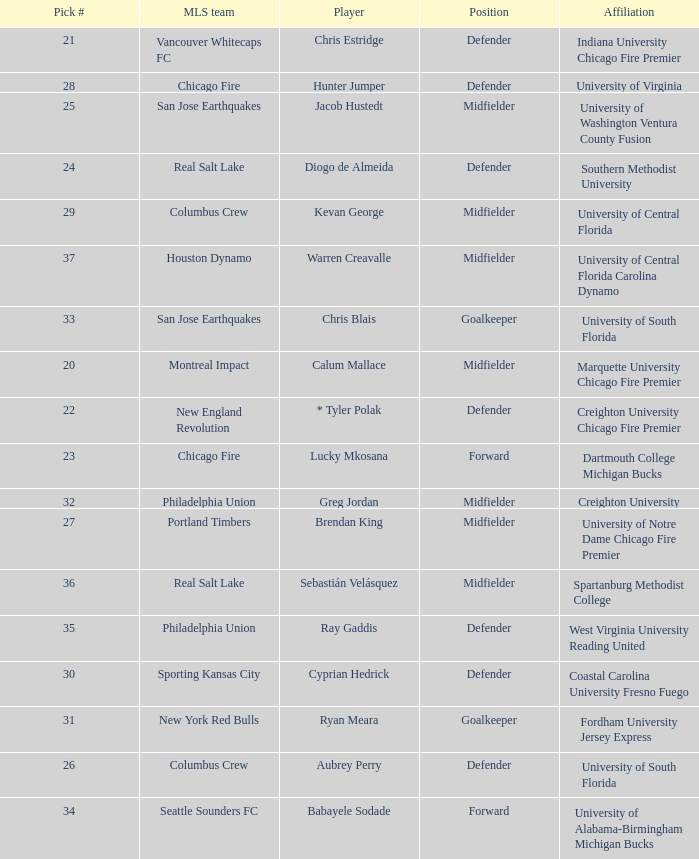What pick number did Real Salt Lake get? 24.0. 